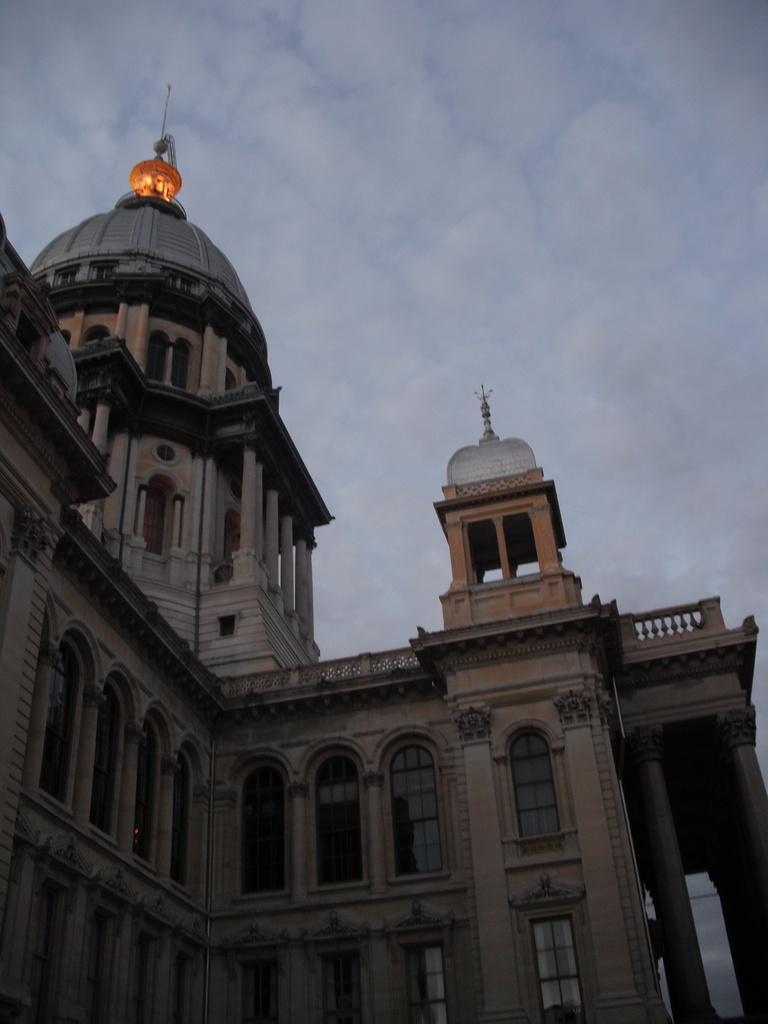Describe this image in one or two sentences. In this image we can see a building with windows, pillars and arches. On the top of the building there is light. In the background there is sky with clouds. 